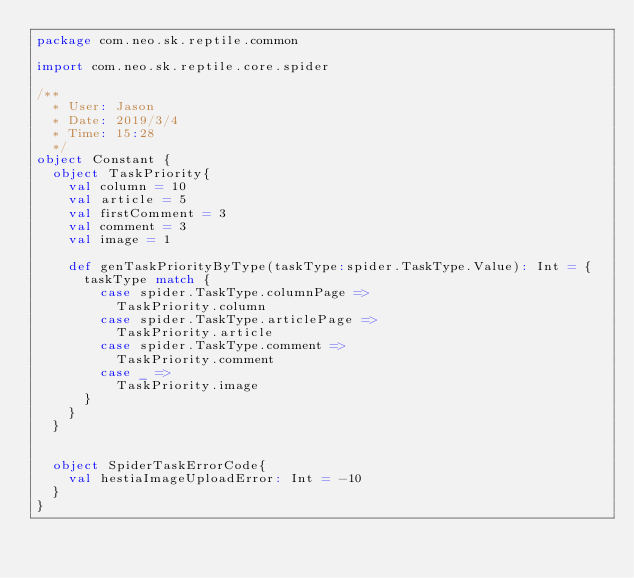<code> <loc_0><loc_0><loc_500><loc_500><_Scala_>package com.neo.sk.reptile.common

import com.neo.sk.reptile.core.spider

/**
  * User: Jason
  * Date: 2019/3/4
  * Time: 15:28
  */
object Constant {
  object TaskPriority{
    val column = 10
    val article = 5
    val firstComment = 3
    val comment = 3
    val image = 1

    def genTaskPriorityByType(taskType:spider.TaskType.Value): Int = {
      taskType match {
        case spider.TaskType.columnPage =>
          TaskPriority.column
        case spider.TaskType.articlePage =>
          TaskPriority.article
        case spider.TaskType.comment =>
          TaskPriority.comment
        case _ =>
          TaskPriority.image
      }
    }
  }


  object SpiderTaskErrorCode{
    val hestiaImageUploadError: Int = -10
  }
}
</code> 